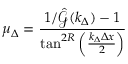<formula> <loc_0><loc_0><loc_500><loc_500>\mu _ { \Delta } = \frac { 1 / \hat { \mathcal { G } } ( k _ { \Delta } ) - 1 } { \tan ^ { 2 R } \left ( \frac { k _ { \Delta } \Delta x } { 2 } \right ) }</formula> 